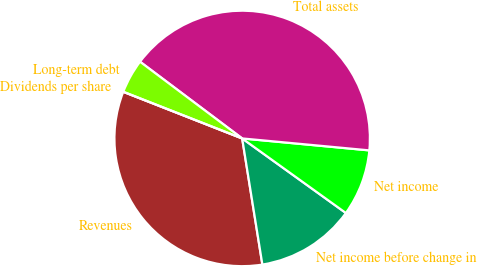<chart> <loc_0><loc_0><loc_500><loc_500><pie_chart><fcel>Revenues<fcel>Net income before change in<fcel>Net income<fcel>Total assets<fcel>Long-term debt<fcel>Dividends per share<nl><fcel>33.48%<fcel>12.55%<fcel>8.43%<fcel>41.24%<fcel>4.3%<fcel>0.0%<nl></chart> 